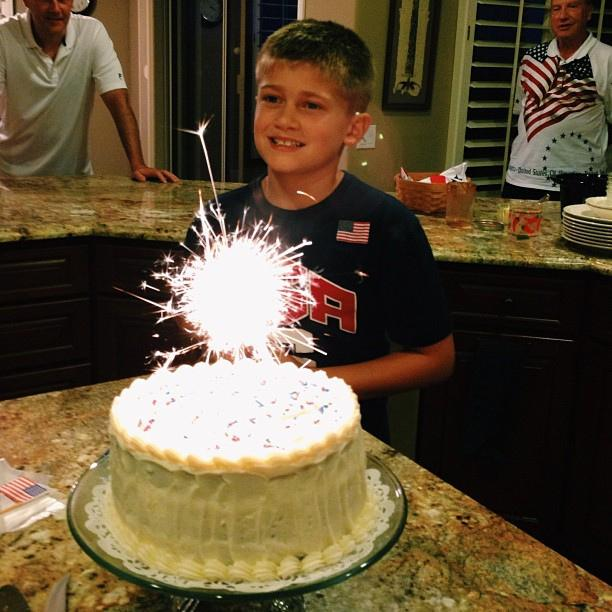What holiday is this cake likeliest to commemorate? birthday 